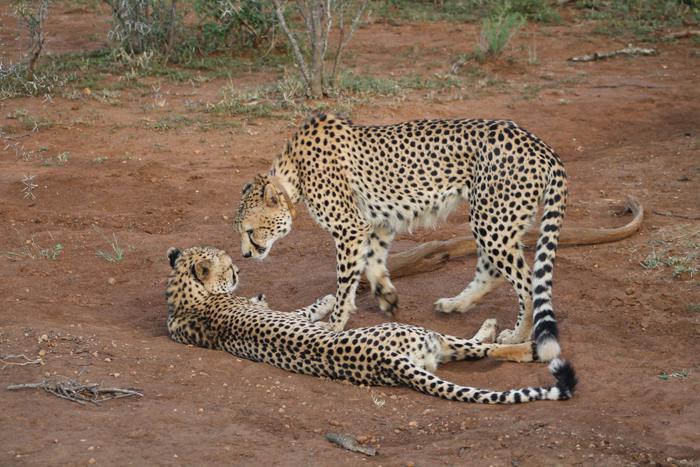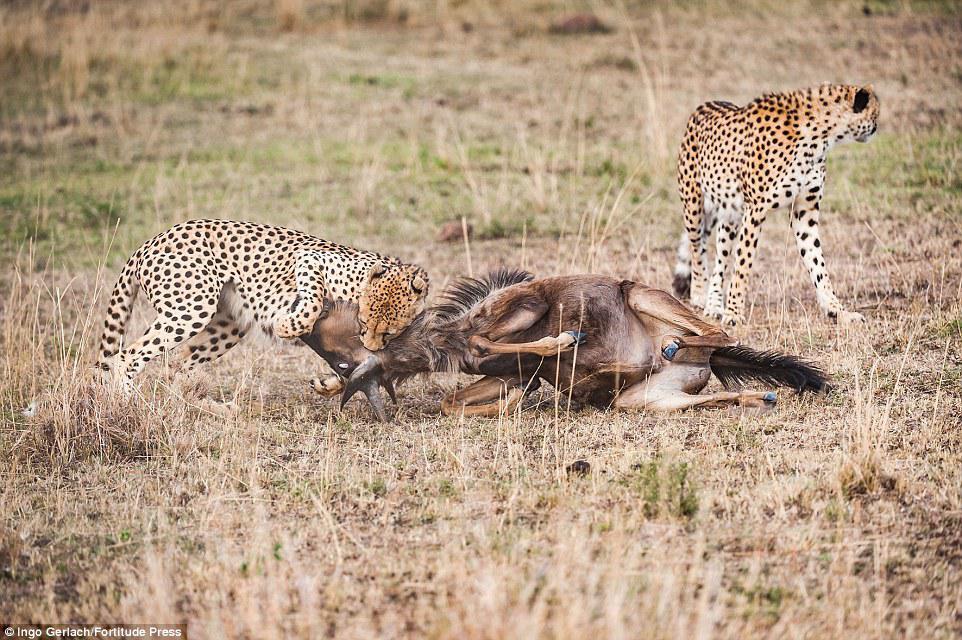The first image is the image on the left, the second image is the image on the right. Given the left and right images, does the statement "An image shows a spotted wild cat taking down its hooved prey." hold true? Answer yes or no. Yes. The first image is the image on the left, the second image is the image on the right. For the images displayed, is the sentence "One or more cheetahs are catching another animal in one of the photos." factually correct? Answer yes or no. Yes. 